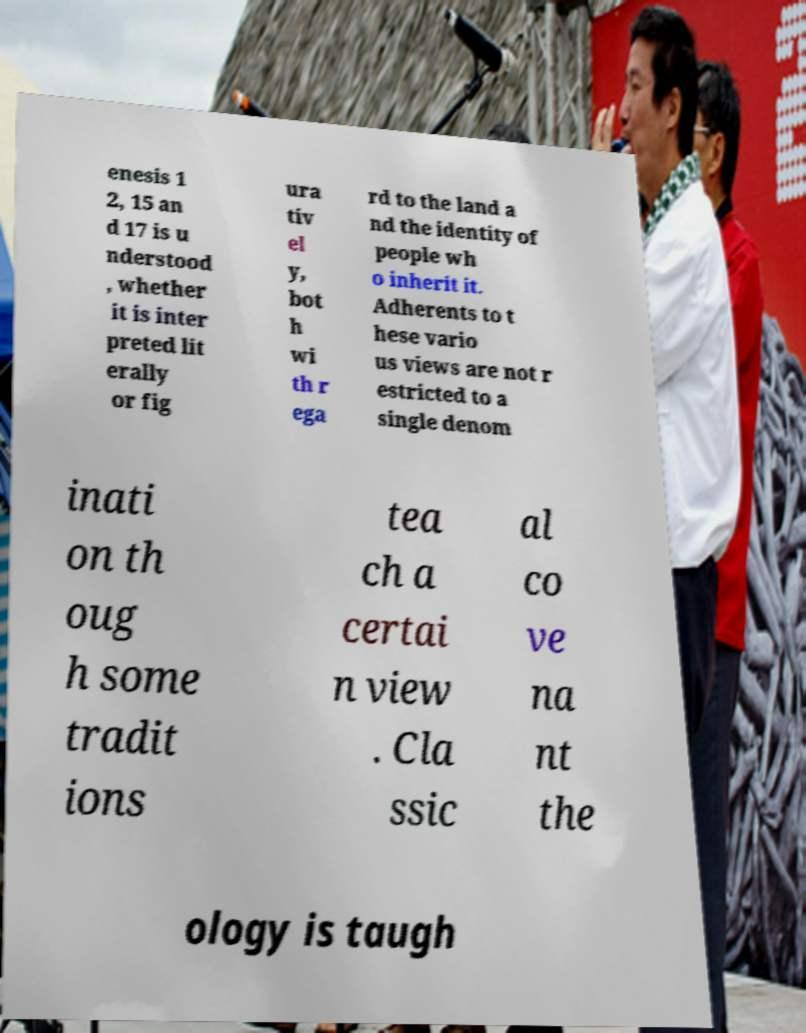There's text embedded in this image that I need extracted. Can you transcribe it verbatim? enesis 1 2, 15 an d 17 is u nderstood , whether it is inter preted lit erally or fig ura tiv el y, bot h wi th r ega rd to the land a nd the identity of people wh o inherit it. Adherents to t hese vario us views are not r estricted to a single denom inati on th oug h some tradit ions tea ch a certai n view . Cla ssic al co ve na nt the ology is taugh 